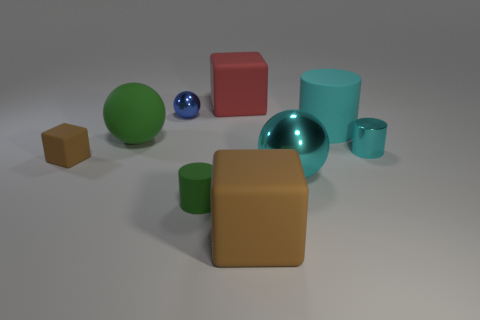Subtract all cubes. How many objects are left? 6 Add 8 tiny rubber blocks. How many tiny rubber blocks are left? 9 Add 9 brown matte spheres. How many brown matte spheres exist? 9 Subtract 0 blue cylinders. How many objects are left? 9 Subtract all big cyan shiny things. Subtract all small rubber cylinders. How many objects are left? 7 